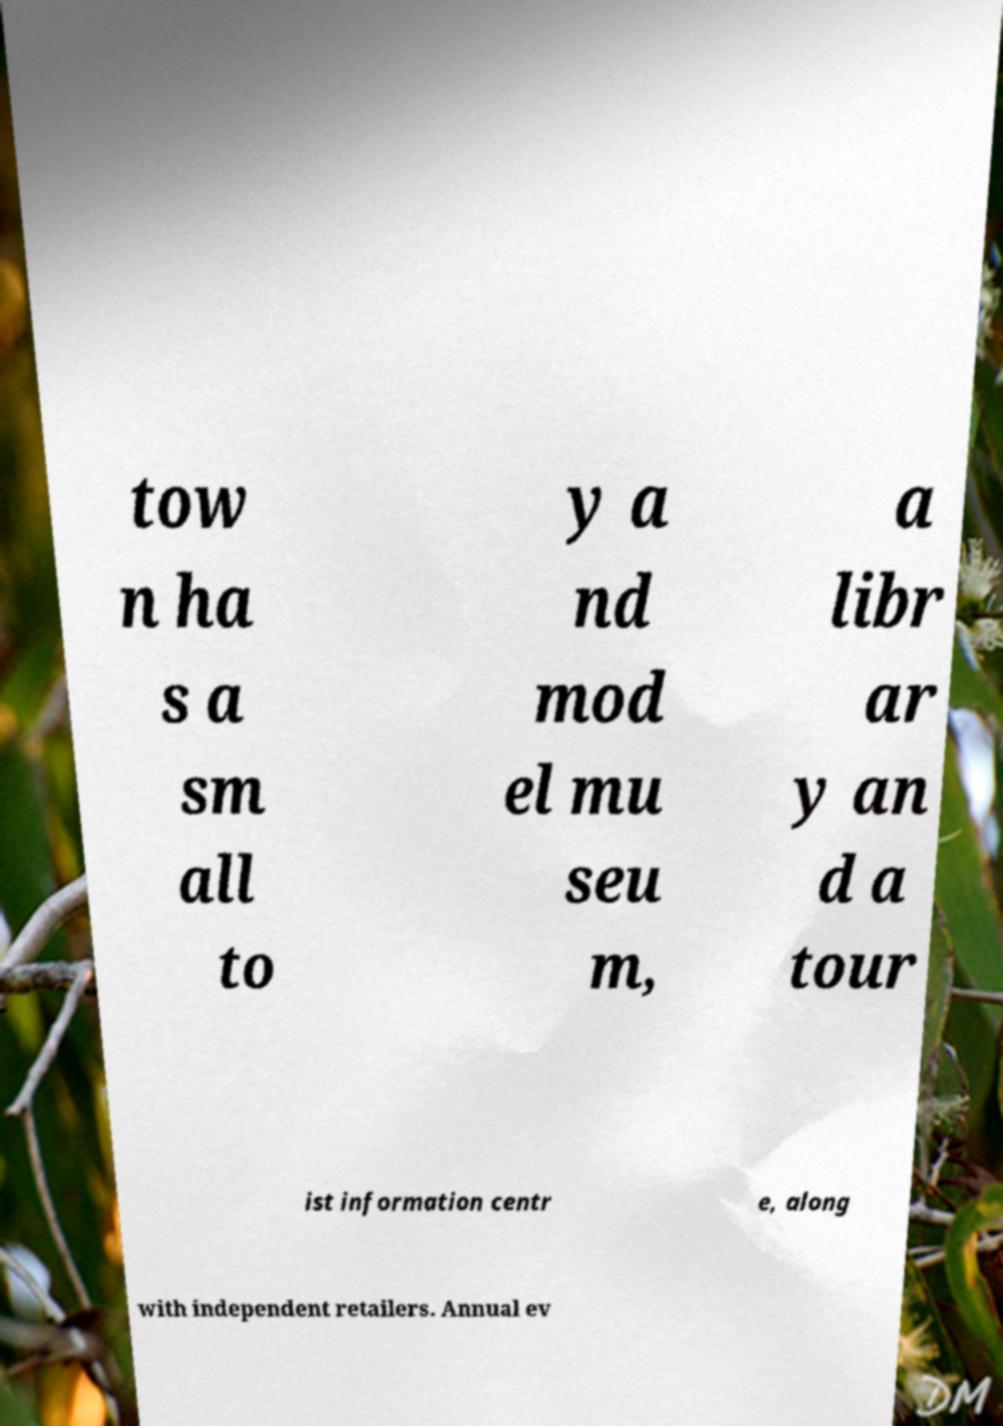There's text embedded in this image that I need extracted. Can you transcribe it verbatim? tow n ha s a sm all to y a nd mod el mu seu m, a libr ar y an d a tour ist information centr e, along with independent retailers. Annual ev 